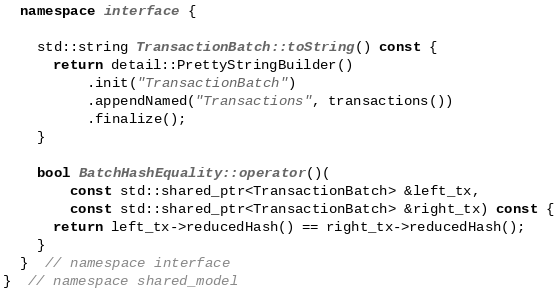Convert code to text. <code><loc_0><loc_0><loc_500><loc_500><_C++_>  namespace interface {

    std::string TransactionBatch::toString() const {
      return detail::PrettyStringBuilder()
          .init("TransactionBatch")
          .appendNamed("Transactions", transactions())
          .finalize();
    }

    bool BatchHashEquality::operator()(
        const std::shared_ptr<TransactionBatch> &left_tx,
        const std::shared_ptr<TransactionBatch> &right_tx) const {
      return left_tx->reducedHash() == right_tx->reducedHash();
    }
  }  // namespace interface
}  // namespace shared_model
</code> 